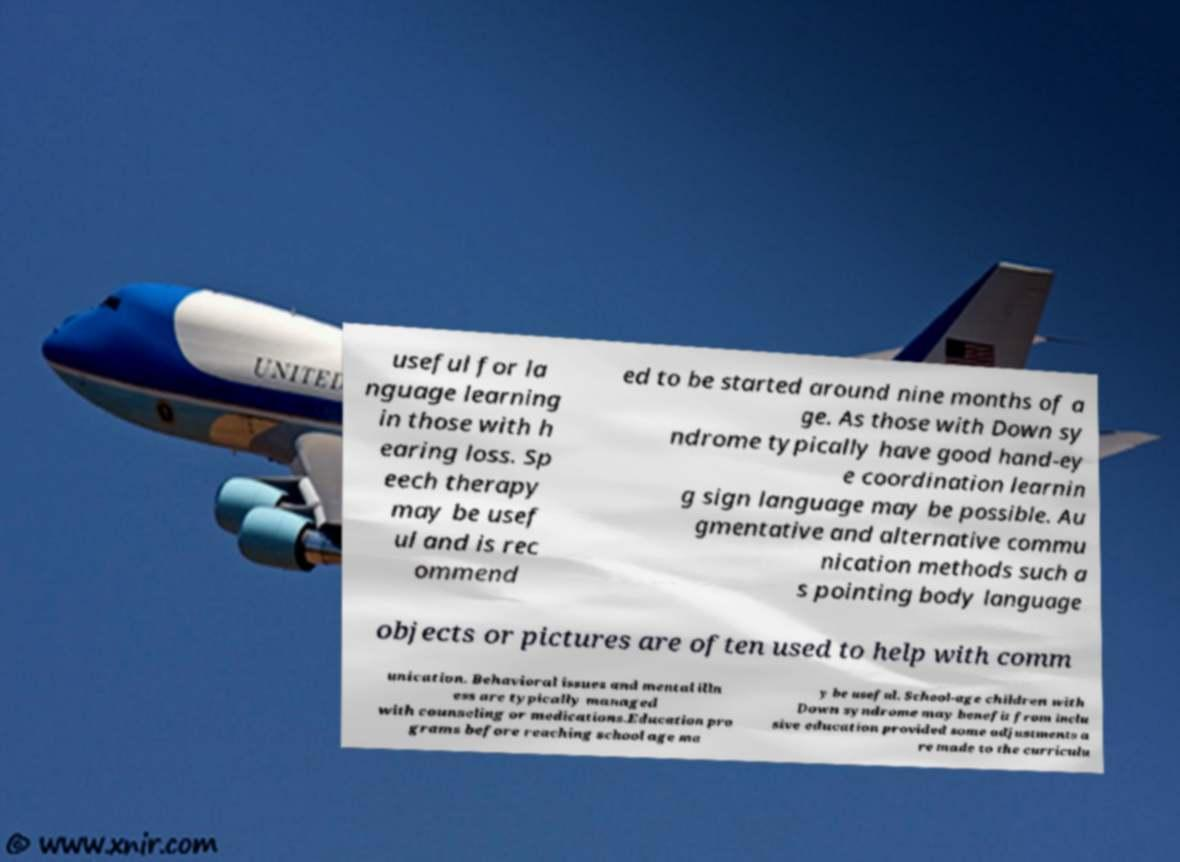Please identify and transcribe the text found in this image. useful for la nguage learning in those with h earing loss. Sp eech therapy may be usef ul and is rec ommend ed to be started around nine months of a ge. As those with Down sy ndrome typically have good hand-ey e coordination learnin g sign language may be possible. Au gmentative and alternative commu nication methods such a s pointing body language objects or pictures are often used to help with comm unication. Behavioral issues and mental illn ess are typically managed with counseling or medications.Education pro grams before reaching school age ma y be useful. School-age children with Down syndrome may benefit from inclu sive education provided some adjustments a re made to the curriculu 